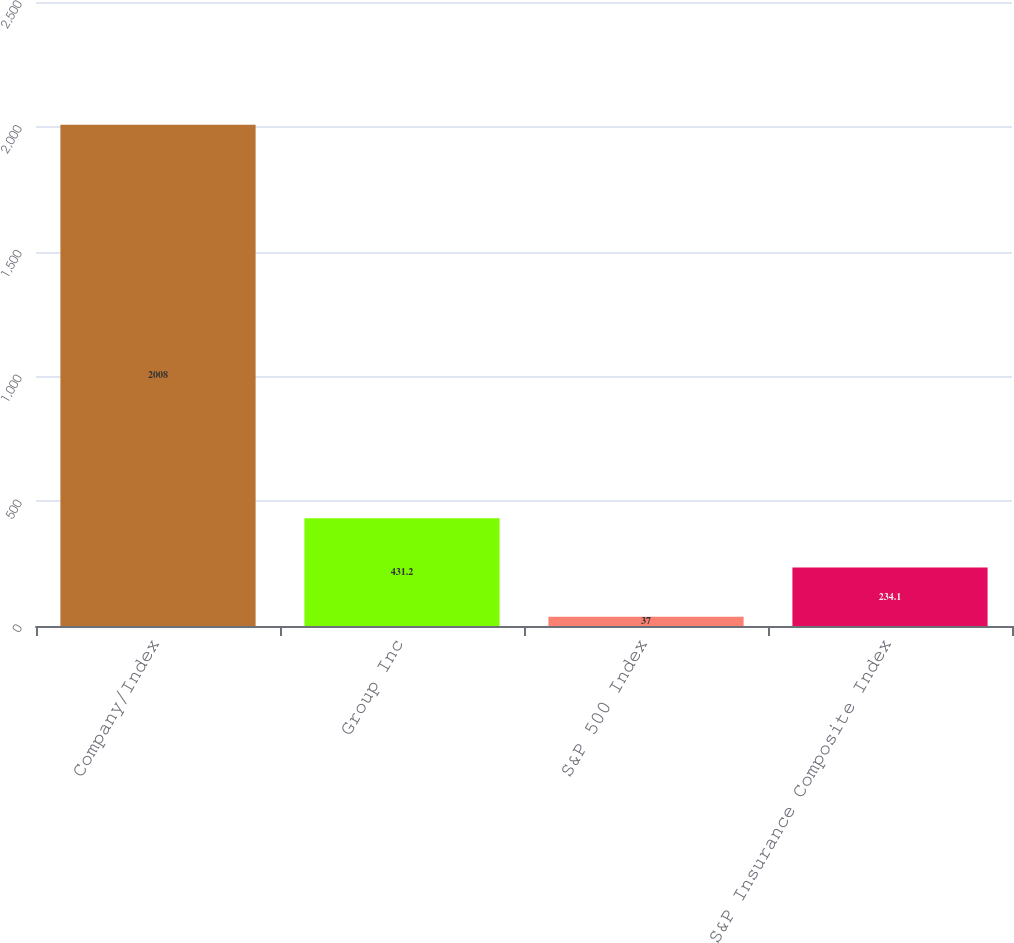Convert chart. <chart><loc_0><loc_0><loc_500><loc_500><bar_chart><fcel>Company/Index<fcel>Group Inc<fcel>S&P 500 Index<fcel>S&P Insurance Composite Index<nl><fcel>2008<fcel>431.2<fcel>37<fcel>234.1<nl></chart> 